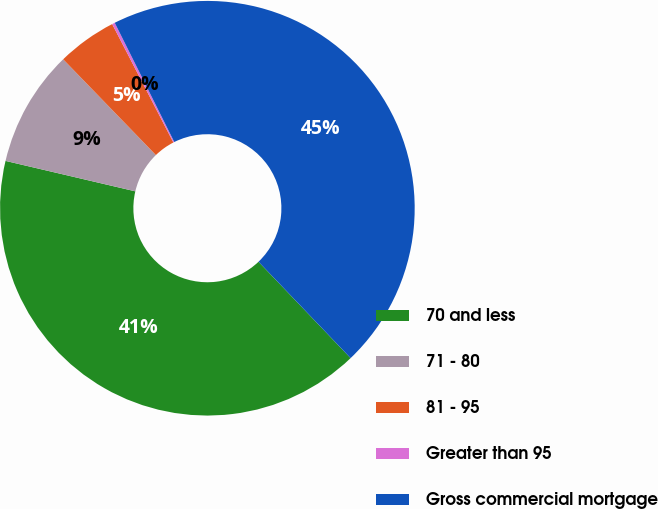Convert chart to OTSL. <chart><loc_0><loc_0><loc_500><loc_500><pie_chart><fcel>70 and less<fcel>71 - 80<fcel>81 - 95<fcel>Greater than 95<fcel>Gross commercial mortgage<nl><fcel>40.8%<fcel>9.09%<fcel>4.65%<fcel>0.22%<fcel>45.23%<nl></chart> 